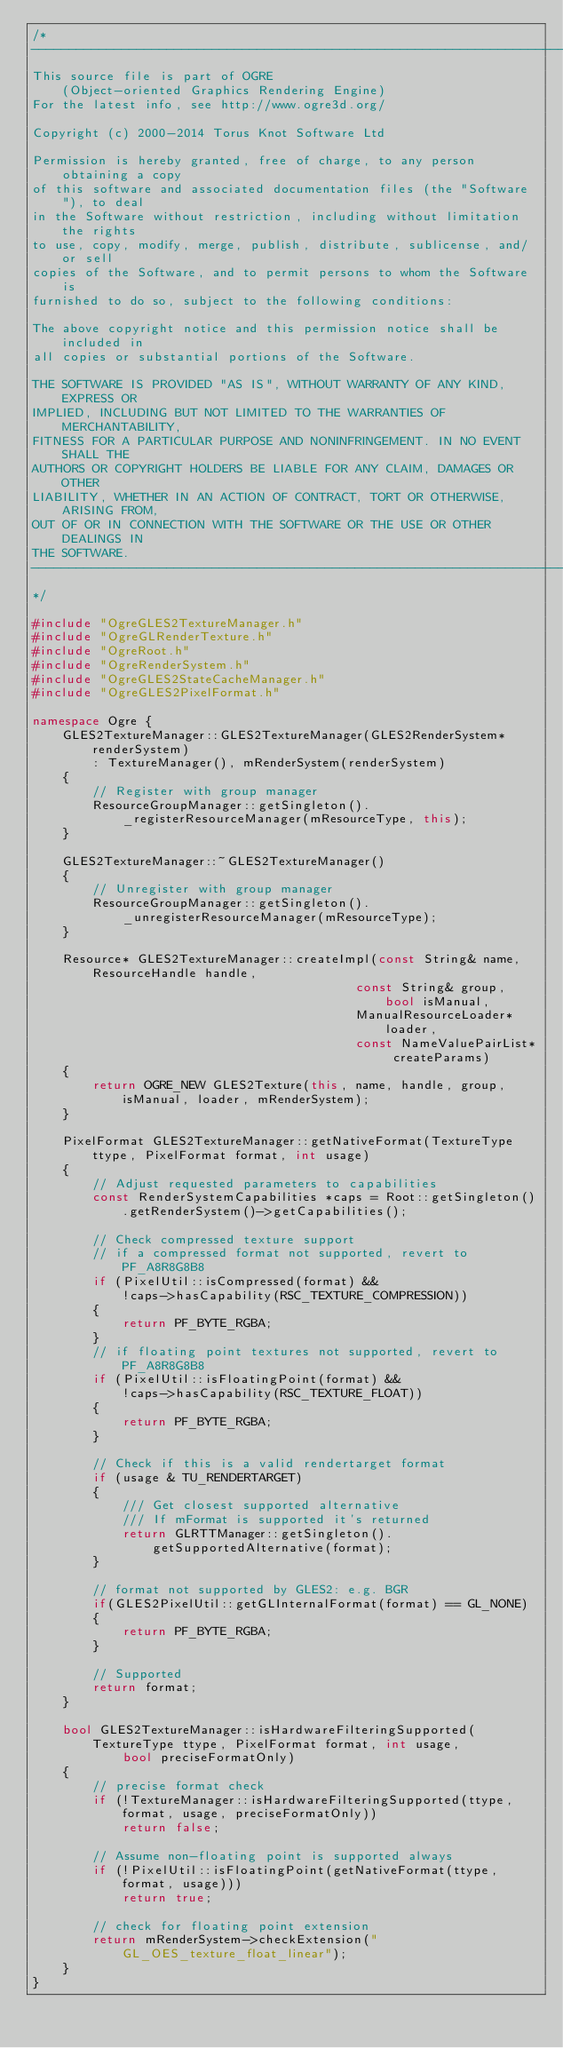<code> <loc_0><loc_0><loc_500><loc_500><_C++_>/*
-----------------------------------------------------------------------------
This source file is part of OGRE
    (Object-oriented Graphics Rendering Engine)
For the latest info, see http://www.ogre3d.org/

Copyright (c) 2000-2014 Torus Knot Software Ltd

Permission is hereby granted, free of charge, to any person obtaining a copy
of this software and associated documentation files (the "Software"), to deal
in the Software without restriction, including without limitation the rights
to use, copy, modify, merge, publish, distribute, sublicense, and/or sell
copies of the Software, and to permit persons to whom the Software is
furnished to do so, subject to the following conditions:

The above copyright notice and this permission notice shall be included in
all copies or substantial portions of the Software.

THE SOFTWARE IS PROVIDED "AS IS", WITHOUT WARRANTY OF ANY KIND, EXPRESS OR
IMPLIED, INCLUDING BUT NOT LIMITED TO THE WARRANTIES OF MERCHANTABILITY,
FITNESS FOR A PARTICULAR PURPOSE AND NONINFRINGEMENT. IN NO EVENT SHALL THE
AUTHORS OR COPYRIGHT HOLDERS BE LIABLE FOR ANY CLAIM, DAMAGES OR OTHER
LIABILITY, WHETHER IN AN ACTION OF CONTRACT, TORT OR OTHERWISE, ARISING FROM,
OUT OF OR IN CONNECTION WITH THE SOFTWARE OR THE USE OR OTHER DEALINGS IN
THE SOFTWARE.
-----------------------------------------------------------------------------
*/

#include "OgreGLES2TextureManager.h"
#include "OgreGLRenderTexture.h"
#include "OgreRoot.h"
#include "OgreRenderSystem.h"
#include "OgreGLES2StateCacheManager.h"
#include "OgreGLES2PixelFormat.h"

namespace Ogre {
    GLES2TextureManager::GLES2TextureManager(GLES2RenderSystem* renderSystem)
        : TextureManager(), mRenderSystem(renderSystem)
    {
        // Register with group manager
        ResourceGroupManager::getSingleton()._registerResourceManager(mResourceType, this);
    }

    GLES2TextureManager::~GLES2TextureManager()
    {
        // Unregister with group manager
        ResourceGroupManager::getSingleton()._unregisterResourceManager(mResourceType);
    }

    Resource* GLES2TextureManager::createImpl(const String& name, ResourceHandle handle, 
                                           const String& group, bool isManual,
                                           ManualResourceLoader* loader,
                                           const NameValuePairList* createParams)
    {
        return OGRE_NEW GLES2Texture(this, name, handle, group, isManual, loader, mRenderSystem);
    }

    PixelFormat GLES2TextureManager::getNativeFormat(TextureType ttype, PixelFormat format, int usage)
    {
        // Adjust requested parameters to capabilities
        const RenderSystemCapabilities *caps = Root::getSingleton().getRenderSystem()->getCapabilities();

        // Check compressed texture support
        // if a compressed format not supported, revert to PF_A8R8G8B8
        if (PixelUtil::isCompressed(format) &&
            !caps->hasCapability(RSC_TEXTURE_COMPRESSION))
        {
            return PF_BYTE_RGBA;
        }
        // if floating point textures not supported, revert to PF_A8R8G8B8
        if (PixelUtil::isFloatingPoint(format) &&
            !caps->hasCapability(RSC_TEXTURE_FLOAT))
        {
            return PF_BYTE_RGBA;
        }

        // Check if this is a valid rendertarget format
        if (usage & TU_RENDERTARGET)
        {
            /// Get closest supported alternative
            /// If mFormat is supported it's returned
            return GLRTTManager::getSingleton().getSupportedAlternative(format);
        }

        // format not supported by GLES2: e.g. BGR
        if(GLES2PixelUtil::getGLInternalFormat(format) == GL_NONE)
        {
            return PF_BYTE_RGBA;
        }

        // Supported
        return format;
    }

    bool GLES2TextureManager::isHardwareFilteringSupported(TextureType ttype, PixelFormat format, int usage,
            bool preciseFormatOnly)
    {
        // precise format check
        if (!TextureManager::isHardwareFilteringSupported(ttype, format, usage, preciseFormatOnly))
            return false;

        // Assume non-floating point is supported always
        if (!PixelUtil::isFloatingPoint(getNativeFormat(ttype, format, usage)))
            return true;
        
        // check for floating point extension
        return mRenderSystem->checkExtension("GL_OES_texture_float_linear");
    }
}
</code> 